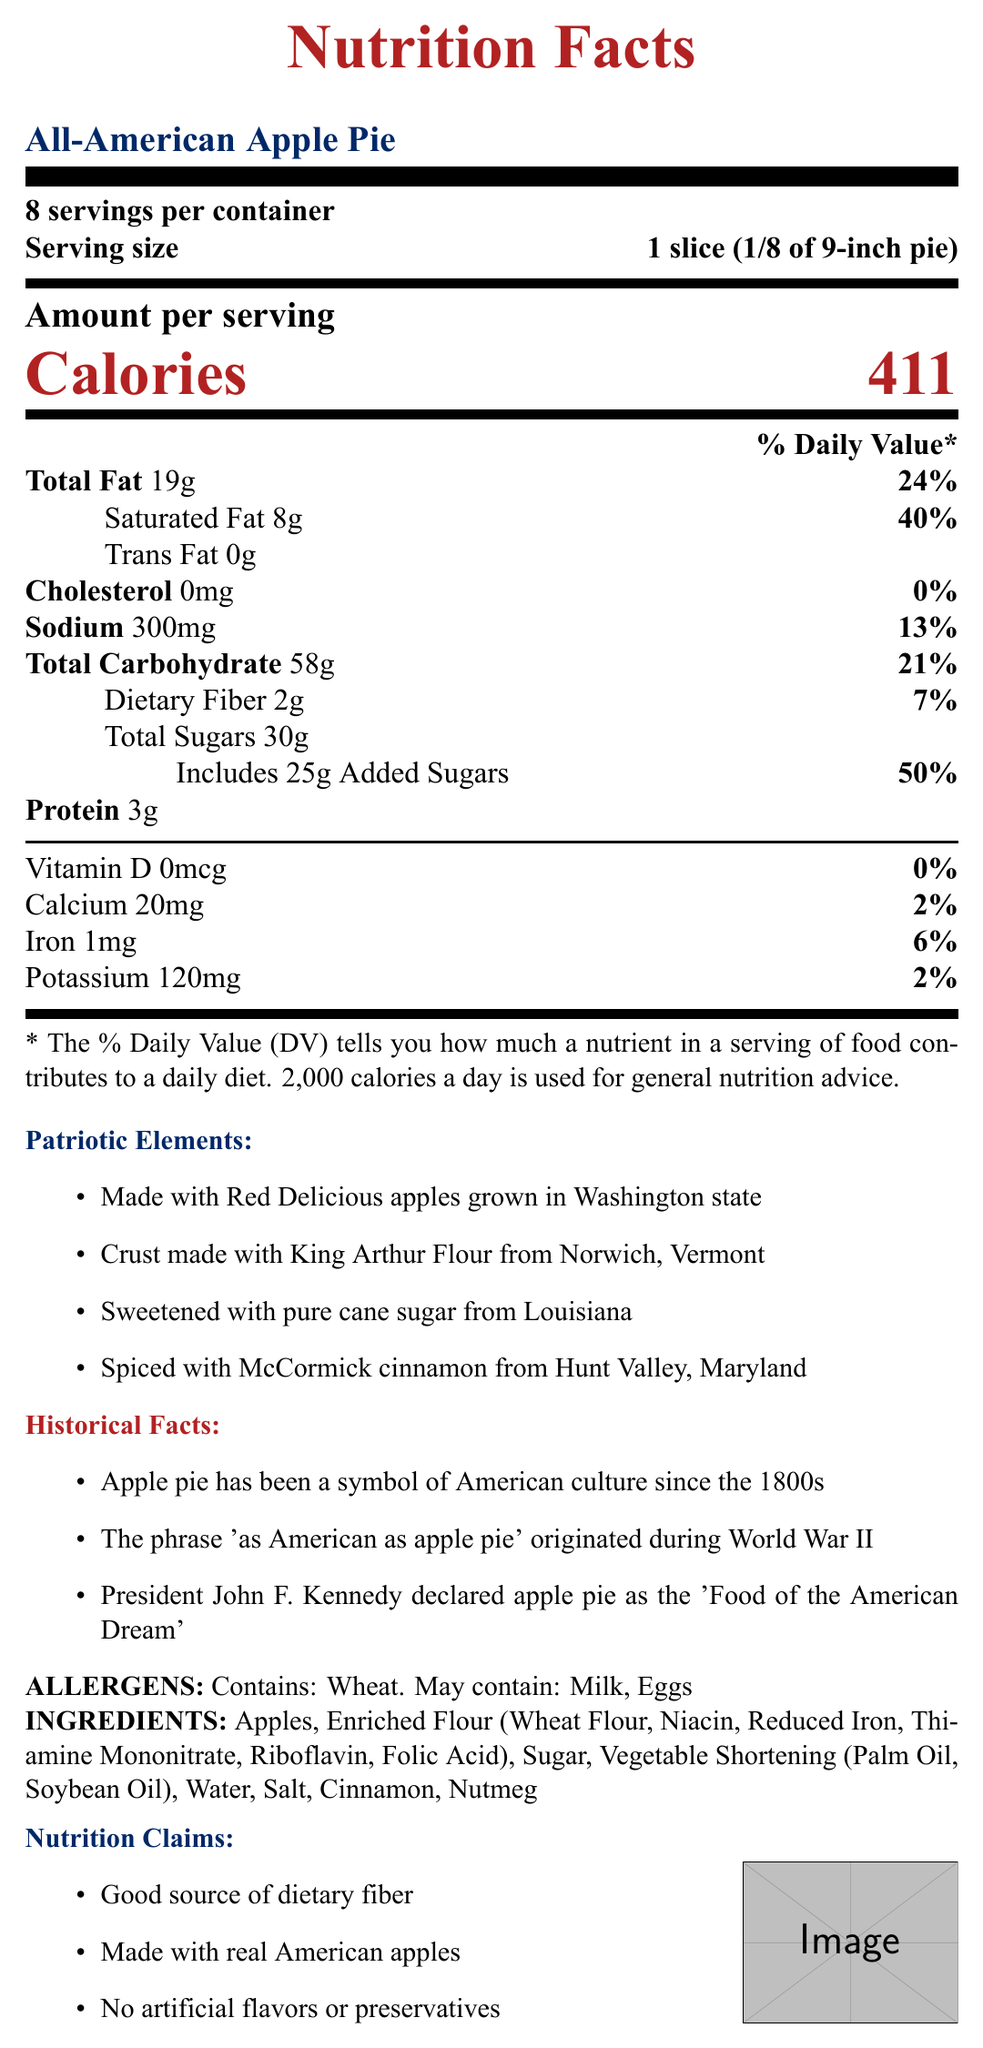What is the serving size for the All-American Apple Pie? The serving size is clearly indicated on the document as "1 slice (1/8 of 9-inch pie)."
Answer: 1 slice (1/8 of 9-inch pie) How many calories are in one serving of the All-American Apple Pie? The document states that each serving of the pie contains 411 calories.
Answer: 411 calories Name two ingredients in the All-American Apple Pie. The ingredients are listed in the document and include apples and enriched flour among others.
Answer: Apples, Enriched Flour Which ingredient in the All-American Apple Pie provides dietary fiber? The document lists apples as an ingredient, which is a common source of dietary fiber.
Answer: Apples What is the daily value percentage of saturated fat in a serving of this pie? The document states that one serving has 8g of saturated fat, which is 40% of the daily value.
Answer: 40% Which state are the Red Delicious apples from? A. Washington B. Vermont C. Louisiana D. Maryland The document mentions that the Red Delicious apples are grown in Washington state.
Answer: A How many grams of total sugars does one serving of the pie contain? A. 25g B. 30g C. 35g D. 40g The document shows that one serving contains 30 grams of total sugars.
Answer: B Does this pie contain any trans fat? The document indicates that the pie contains 0 grams of trans fat.
Answer: No What is one of the historical facts mentioned about apple pie? One of the historical facts listed in the document is that the phrase "As American as apple pie" originated during World War II.
Answer: "As American as apple pie" originated during World War II Summarize the main connections to American patriotism in this document. The summary captures how the document ties the apple pie to American patriotism through its ingredients and historical significance.
Answer: The All-American Apple Pie emphasizes its patriotic roots by using ingredients sourced from various American states: Red Delicious apples from Washington, King Arthur Flour from Vermont, cane sugar from Louisiana, and McCormick cinnamon from Maryland. Additionally, the document highlights historical facts, such as apple pie being a symbol of American culture since the 1800s and mentioned by President John F. Kennedy as the "Food of the American Dream." Which historical fact is mentioned that cannot be verified by this document? The document states multiple historical facts about apple pie, but it does not provide evidence or sources to verify these claims.
Answer: Not enough information 